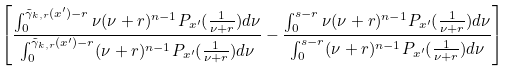Convert formula to latex. <formula><loc_0><loc_0><loc_500><loc_500>\left [ \frac { \int ^ { \tilde { \gamma } _ { k , r } ( x ^ { \prime } ) - r } _ { 0 } \nu ( \nu + r ) ^ { n - 1 } P _ { x ^ { \prime } } ( \frac { 1 } { \nu + r } ) d \nu } { \int ^ { \tilde { \gamma } _ { k , r } ( x ^ { \prime } ) - r } _ { 0 } ( \nu + r ) ^ { n - 1 } P _ { x ^ { \prime } } ( \frac { 1 } { \nu + r } ) d \nu } - \frac { \int ^ { s - r } _ { 0 } \nu ( \nu + r ) ^ { n - 1 } P _ { x ^ { \prime } } ( \frac { 1 } { \nu + r } ) d \nu } { \int ^ { s - r } _ { 0 } ( \nu + r ) ^ { n - 1 } P _ { x ^ { \prime } } ( \frac { 1 } { \nu + r } ) d \nu } \right ]</formula> 